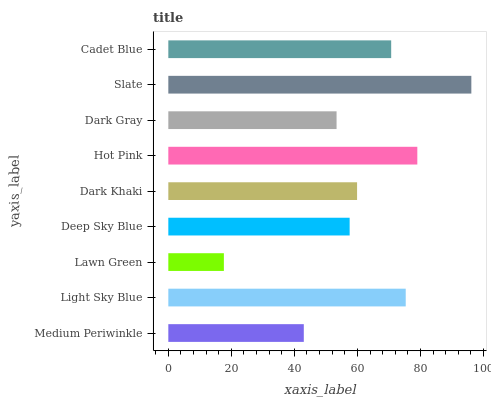Is Lawn Green the minimum?
Answer yes or no. Yes. Is Slate the maximum?
Answer yes or no. Yes. Is Light Sky Blue the minimum?
Answer yes or no. No. Is Light Sky Blue the maximum?
Answer yes or no. No. Is Light Sky Blue greater than Medium Periwinkle?
Answer yes or no. Yes. Is Medium Periwinkle less than Light Sky Blue?
Answer yes or no. Yes. Is Medium Periwinkle greater than Light Sky Blue?
Answer yes or no. No. Is Light Sky Blue less than Medium Periwinkle?
Answer yes or no. No. Is Dark Khaki the high median?
Answer yes or no. Yes. Is Dark Khaki the low median?
Answer yes or no. Yes. Is Slate the high median?
Answer yes or no. No. Is Cadet Blue the low median?
Answer yes or no. No. 